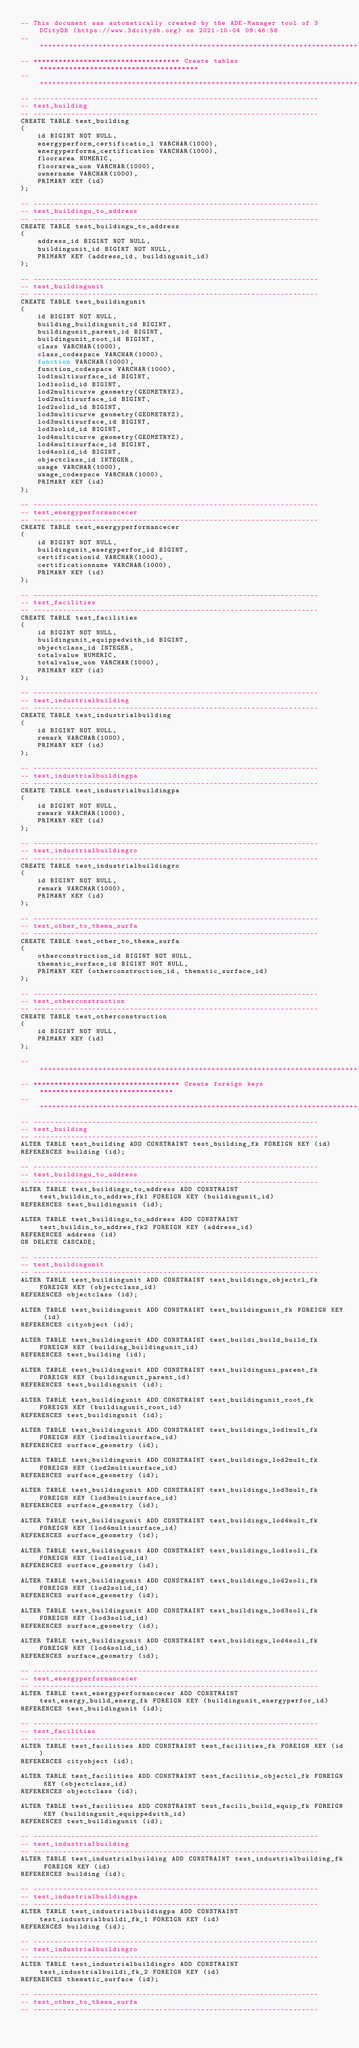Convert code to text. <code><loc_0><loc_0><loc_500><loc_500><_SQL_>-- This document was automatically created by the ADE-Manager tool of 3DCityDB (https://www.3dcitydb.org) on 2021-10-04 09:46:58 
-- ++++++++++++++++++++++++++++++++++++++++++++++++++++++++++++++++++++++++++++++++++++++++ 
-- *********************************** Create tables ************************************** 
-- ++++++++++++++++++++++++++++++++++++++++++++++++++++++++++++++++++++++++++++++++++++++++ 
-- -------------------------------------------------------------------- 
-- test_building 
-- -------------------------------------------------------------------- 
CREATE TABLE test_building
(
    id BIGINT NOT NULL,
    energyperform_certificatio_1 VARCHAR(1000),
    energyperforma_certification VARCHAR(1000),
    floorarea NUMERIC,
    floorarea_uom VARCHAR(1000),
    ownername VARCHAR(1000),
    PRIMARY KEY (id)
);

-- -------------------------------------------------------------------- 
-- test_buildingu_to_address 
-- -------------------------------------------------------------------- 
CREATE TABLE test_buildingu_to_address
(
    address_id BIGINT NOT NULL,
    buildingunit_id BIGINT NOT NULL,
    PRIMARY KEY (address_id, buildingunit_id)
);

-- -------------------------------------------------------------------- 
-- test_buildingunit 
-- -------------------------------------------------------------------- 
CREATE TABLE test_buildingunit
(
    id BIGINT NOT NULL,
    building_buildingunit_id BIGINT,
    buildingunit_parent_id BIGINT,
    buildingunit_root_id BIGINT,
    class VARCHAR(1000),
    class_codespace VARCHAR(1000),
    function VARCHAR(1000),
    function_codespace VARCHAR(1000),
    lod1multisurface_id BIGINT,
    lod1solid_id BIGINT,
    lod2multicurve geometry(GEOMETRYZ),
    lod2multisurface_id BIGINT,
    lod2solid_id BIGINT,
    lod3multicurve geometry(GEOMETRYZ),
    lod3multisurface_id BIGINT,
    lod3solid_id BIGINT,
    lod4multicurve geometry(GEOMETRYZ),
    lod4multisurface_id BIGINT,
    lod4solid_id BIGINT,
    objectclass_id INTEGER,
    usage VARCHAR(1000),
    usage_codespace VARCHAR(1000),
    PRIMARY KEY (id)
);

-- -------------------------------------------------------------------- 
-- test_energyperformancecer 
-- -------------------------------------------------------------------- 
CREATE TABLE test_energyperformancecer
(
    id BIGINT NOT NULL,
    buildingunit_energyperfor_id BIGINT,
    certificationid VARCHAR(1000),
    certificationname VARCHAR(1000),
    PRIMARY KEY (id)
);

-- -------------------------------------------------------------------- 
-- test_facilities 
-- -------------------------------------------------------------------- 
CREATE TABLE test_facilities
(
    id BIGINT NOT NULL,
    buildingunit_equippedwith_id BIGINT,
    objectclass_id INTEGER,
    totalvalue NUMERIC,
    totalvalue_uom VARCHAR(1000),
    PRIMARY KEY (id)
);

-- -------------------------------------------------------------------- 
-- test_industrialbuilding 
-- -------------------------------------------------------------------- 
CREATE TABLE test_industrialbuilding
(
    id BIGINT NOT NULL,
    remark VARCHAR(1000),
    PRIMARY KEY (id)
);

-- -------------------------------------------------------------------- 
-- test_industrialbuildingpa 
-- -------------------------------------------------------------------- 
CREATE TABLE test_industrialbuildingpa
(
    id BIGINT NOT NULL,
    remark VARCHAR(1000),
    PRIMARY KEY (id)
);

-- -------------------------------------------------------------------- 
-- test_industrialbuildingro 
-- -------------------------------------------------------------------- 
CREATE TABLE test_industrialbuildingro
(
    id BIGINT NOT NULL,
    remark VARCHAR(1000),
    PRIMARY KEY (id)
);

-- -------------------------------------------------------------------- 
-- test_other_to_thema_surfa 
-- -------------------------------------------------------------------- 
CREATE TABLE test_other_to_thema_surfa
(
    otherconstruction_id BIGINT NOT NULL,
    thematic_surface_id BIGINT NOT NULL,
    PRIMARY KEY (otherconstruction_id, thematic_surface_id)
);

-- -------------------------------------------------------------------- 
-- test_otherconstruction 
-- -------------------------------------------------------------------- 
CREATE TABLE test_otherconstruction
(
    id BIGINT NOT NULL,
    PRIMARY KEY (id)
);

-- ++++++++++++++++++++++++++++++++++++++++++++++++++++++++++++++++++++++++++++++++++++++++ 
-- *********************************** Create foreign keys ******************************** 
-- ++++++++++++++++++++++++++++++++++++++++++++++++++++++++++++++++++++++++++++++++++++++++ 
-- -------------------------------------------------------------------- 
-- test_building 
-- -------------------------------------------------------------------- 
ALTER TABLE test_building ADD CONSTRAINT test_building_fk FOREIGN KEY (id)
REFERENCES building (id);

-- -------------------------------------------------------------------- 
-- test_buildingu_to_address 
-- -------------------------------------------------------------------- 
ALTER TABLE test_buildingu_to_address ADD CONSTRAINT test_buildin_to_addres_fk1 FOREIGN KEY (buildingunit_id)
REFERENCES test_buildingunit (id);

ALTER TABLE test_buildingu_to_address ADD CONSTRAINT test_buildin_to_addres_fk2 FOREIGN KEY (address_id)
REFERENCES address (id)
ON DELETE CASCADE;

-- -------------------------------------------------------------------- 
-- test_buildingunit 
-- -------------------------------------------------------------------- 
ALTER TABLE test_buildingunit ADD CONSTRAINT test_buildingu_objectcl_fk FOREIGN KEY (objectclass_id)
REFERENCES objectclass (id);

ALTER TABLE test_buildingunit ADD CONSTRAINT test_buildingunit_fk FOREIGN KEY (id)
REFERENCES cityobject (id);

ALTER TABLE test_buildingunit ADD CONSTRAINT test_buildi_build_build_fk FOREIGN KEY (building_buildingunit_id)
REFERENCES test_building (id);

ALTER TABLE test_buildingunit ADD CONSTRAINT test_buildinguni_parent_fk FOREIGN KEY (buildingunit_parent_id)
REFERENCES test_buildingunit (id);

ALTER TABLE test_buildingunit ADD CONSTRAINT test_buildingunit_root_fk FOREIGN KEY (buildingunit_root_id)
REFERENCES test_buildingunit (id);

ALTER TABLE test_buildingunit ADD CONSTRAINT test_buildingu_lod1mult_fk FOREIGN KEY (lod1multisurface_id)
REFERENCES surface_geometry (id);

ALTER TABLE test_buildingunit ADD CONSTRAINT test_buildingu_lod2mult_fk FOREIGN KEY (lod2multisurface_id)
REFERENCES surface_geometry (id);

ALTER TABLE test_buildingunit ADD CONSTRAINT test_buildingu_lod3mult_fk FOREIGN KEY (lod3multisurface_id)
REFERENCES surface_geometry (id);

ALTER TABLE test_buildingunit ADD CONSTRAINT test_buildingu_lod4mult_fk FOREIGN KEY (lod4multisurface_id)
REFERENCES surface_geometry (id);

ALTER TABLE test_buildingunit ADD CONSTRAINT test_buildingu_lod1soli_fk FOREIGN KEY (lod1solid_id)
REFERENCES surface_geometry (id);

ALTER TABLE test_buildingunit ADD CONSTRAINT test_buildingu_lod2soli_fk FOREIGN KEY (lod2solid_id)
REFERENCES surface_geometry (id);

ALTER TABLE test_buildingunit ADD CONSTRAINT test_buildingu_lod3soli_fk FOREIGN KEY (lod3solid_id)
REFERENCES surface_geometry (id);

ALTER TABLE test_buildingunit ADD CONSTRAINT test_buildingu_lod4soli_fk FOREIGN KEY (lod4solid_id)
REFERENCES surface_geometry (id);

-- -------------------------------------------------------------------- 
-- test_energyperformancecer 
-- -------------------------------------------------------------------- 
ALTER TABLE test_energyperformancecer ADD CONSTRAINT test_energy_build_energ_fk FOREIGN KEY (buildingunit_energyperfor_id)
REFERENCES test_buildingunit (id);

-- -------------------------------------------------------------------- 
-- test_facilities 
-- -------------------------------------------------------------------- 
ALTER TABLE test_facilities ADD CONSTRAINT test_facilities_fk FOREIGN KEY (id)
REFERENCES cityobject (id);

ALTER TABLE test_facilities ADD CONSTRAINT test_facilitie_objectcl_fk FOREIGN KEY (objectclass_id)
REFERENCES objectclass (id);

ALTER TABLE test_facilities ADD CONSTRAINT test_facili_build_equip_fk FOREIGN KEY (buildingunit_equippedwith_id)
REFERENCES test_buildingunit (id);

-- -------------------------------------------------------------------- 
-- test_industrialbuilding 
-- -------------------------------------------------------------------- 
ALTER TABLE test_industrialbuilding ADD CONSTRAINT test_industrialbuilding_fk FOREIGN KEY (id)
REFERENCES building (id);

-- -------------------------------------------------------------------- 
-- test_industrialbuildingpa 
-- -------------------------------------------------------------------- 
ALTER TABLE test_industrialbuildingpa ADD CONSTRAINT test_industrialbuildi_fk_1 FOREIGN KEY (id)
REFERENCES building (id);

-- -------------------------------------------------------------------- 
-- test_industrialbuildingro 
-- -------------------------------------------------------------------- 
ALTER TABLE test_industrialbuildingro ADD CONSTRAINT test_industrialbuildi_fk_2 FOREIGN KEY (id)
REFERENCES thematic_surface (id);

-- -------------------------------------------------------------------- 
-- test_other_to_thema_surfa 
-- -------------------------------------------------------------------- </code> 